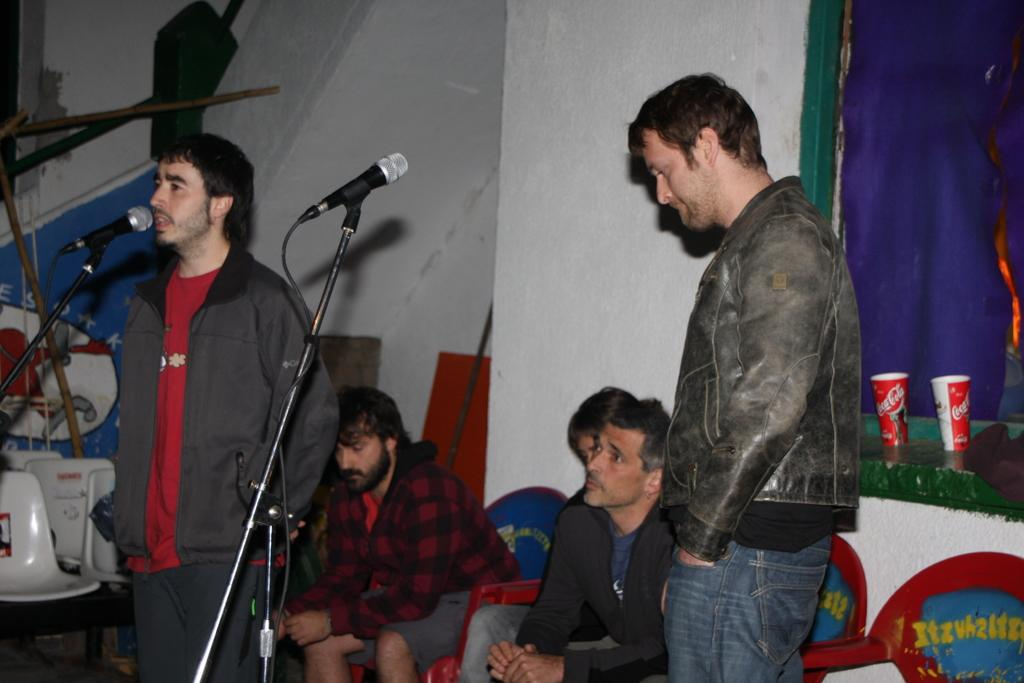Who or what is present in the image? There are people in the image. What objects are related to sound in the image? There are microphones (mics) and mic stands in the image. What objects are used for holding or drinking in the image? There are cups in the image. What type of covering is present in the image? There is a curtain in the image. What type of furniture is present in the image? There are chairs in the image. How many people are sitting on chairs in the image? Three people are sitting on chairs in the image. How many people are standing in the image? Two people are standing in the image. What type of plant is being burned in the image? There is no plant being burned in the image. What type of death is depicted in the image? There is no death depicted in the image. 